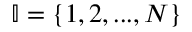Convert formula to latex. <formula><loc_0><loc_0><loc_500><loc_500>\mathbb { I } = \{ 1 , 2 , \dots , N \}</formula> 